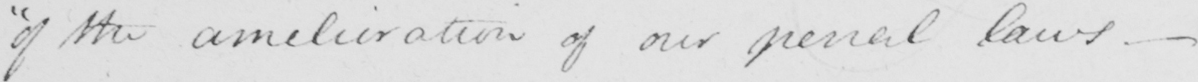Please provide the text content of this handwritten line. " of the amelioration of our penallaws  _ 